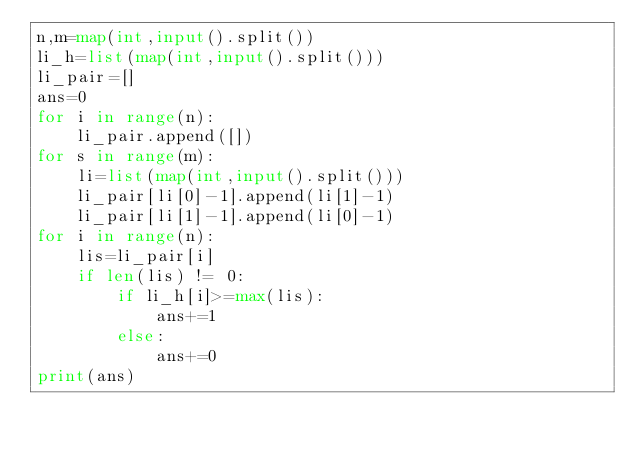Convert code to text. <code><loc_0><loc_0><loc_500><loc_500><_Python_>n,m=map(int,input().split())
li_h=list(map(int,input().split()))
li_pair=[]
ans=0
for i in range(n):
    li_pair.append([])
for s in range(m):
    li=list(map(int,input().split()))
    li_pair[li[0]-1].append(li[1]-1)
    li_pair[li[1]-1].append(li[0]-1)
for i in range(n):
    lis=li_pair[i]
    if len(lis) != 0:
        if li_h[i]>=max(lis):
            ans+=1
        else:
            ans+=0
print(ans)</code> 